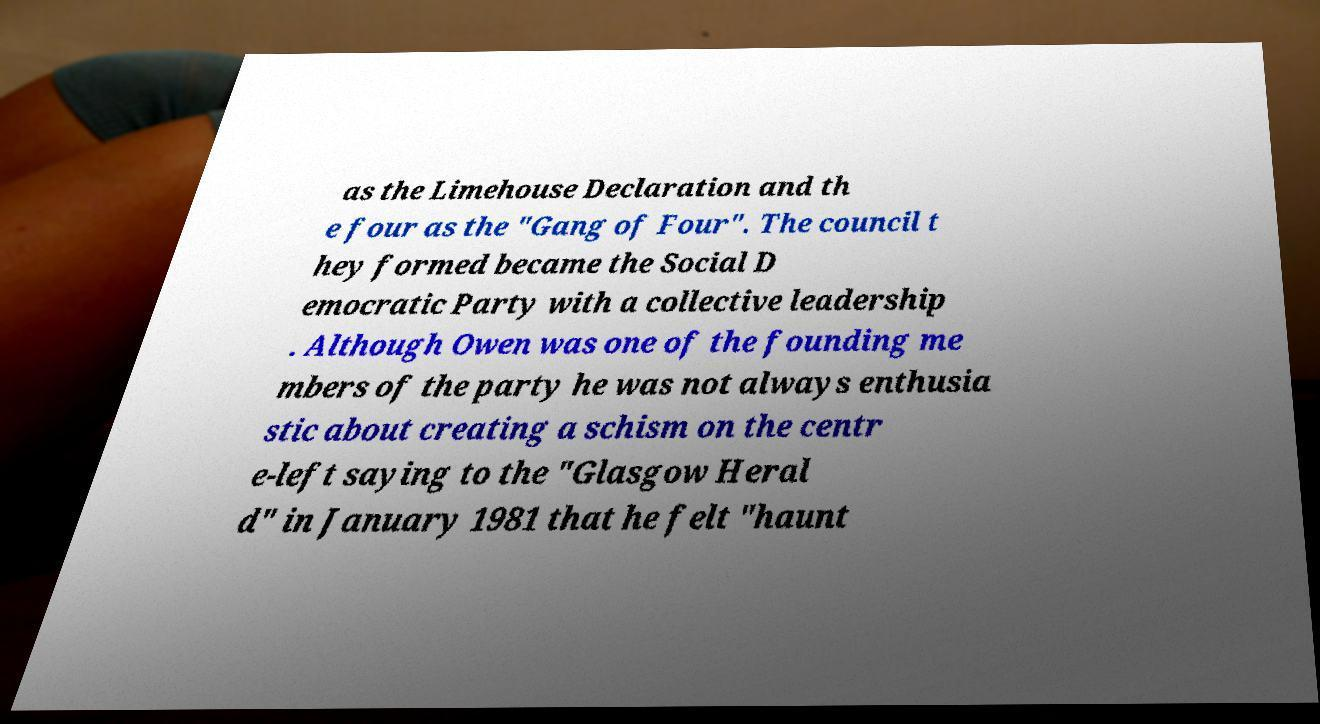Please read and relay the text visible in this image. What does it say? as the Limehouse Declaration and th e four as the "Gang of Four". The council t hey formed became the Social D emocratic Party with a collective leadership . Although Owen was one of the founding me mbers of the party he was not always enthusia stic about creating a schism on the centr e-left saying to the "Glasgow Heral d" in January 1981 that he felt "haunt 